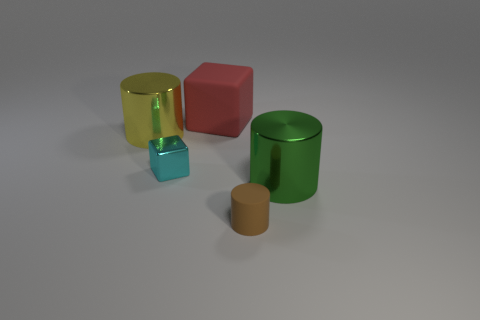What is the shape of the large metal object right of the small thing that is in front of the small shiny object?
Offer a very short reply. Cylinder. Do the metallic cylinder that is to the right of the red block and the rubber cylinder have the same size?
Provide a succinct answer. No. There is a thing that is on the right side of the small cyan thing and behind the large green shiny cylinder; what size is it?
Your answer should be compact. Large. What number of green metal cylinders have the same size as the brown cylinder?
Provide a succinct answer. 0. There is a tiny metal cube left of the small rubber object; how many tiny brown things are to the left of it?
Your response must be concise. 0. Do the tiny object that is left of the red object and the small cylinder have the same color?
Keep it short and to the point. No. Are there any big cylinders behind the green cylinder in front of the metallic cylinder to the left of the shiny block?
Keep it short and to the point. Yes. What is the shape of the large object that is on the right side of the yellow cylinder and behind the green shiny object?
Provide a succinct answer. Cube. Is there a small cylinder that has the same color as the big rubber cube?
Give a very brief answer. No. What is the color of the big metallic thing that is behind the big cylinder on the right side of the big red matte cube?
Ensure brevity in your answer.  Yellow. 